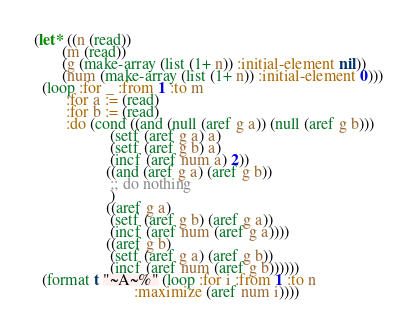Convert code to text. <code><loc_0><loc_0><loc_500><loc_500><_Lisp_>(let* ((n (read))
       (m (read))
       (g (make-array (list (1+ n)) :initial-element nil))
       (num (make-array (list (1+ n)) :initial-element 0)))
  (loop :for _ :from 1 :to m
        :for a := (read)
        :for b := (read)
        :do (cond ((and (null (aref g a)) (null (aref g b)))
                   (setf (aref g a) a)
                   (setf (aref g b) a)
                   (incf (aref num a) 2))
                  ((and (aref g a) (aref g b))
                   ;; do nothing
                   )
                  ((aref g a)
                   (setf (aref g b) (aref g a))
                   (incf (aref num (aref g a))))
                  ((aref g b)
                   (setf (aref g a) (aref g b))
                   (incf (aref num (aref g b))))))
  (format t "~A~%" (loop :for i :from 1 :to n
                         :maximize (aref num i))))
</code> 